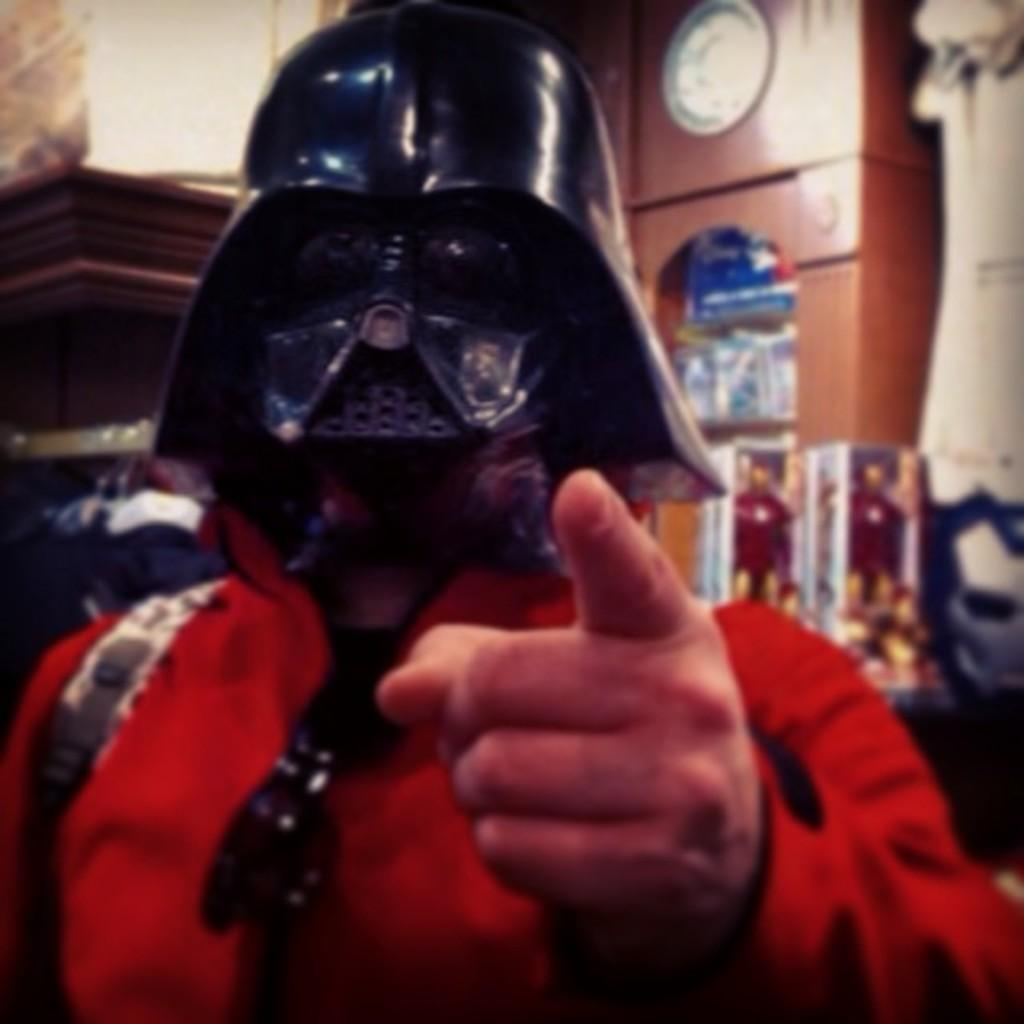What is the person in the image wearing on their head? The person is wearing a helmet in the image. What is the person carrying in the image? The person is carrying a bag in the image. What time-related object is visible in the image? There is a clock visible in the image. What can be seen in the background of the image? There are other items present in the background of the image. What type of advice can be seen written on the person's toe in the image? There is no advice written on the person's toe in the image, as the person is wearing a helmet and carrying a bag. 